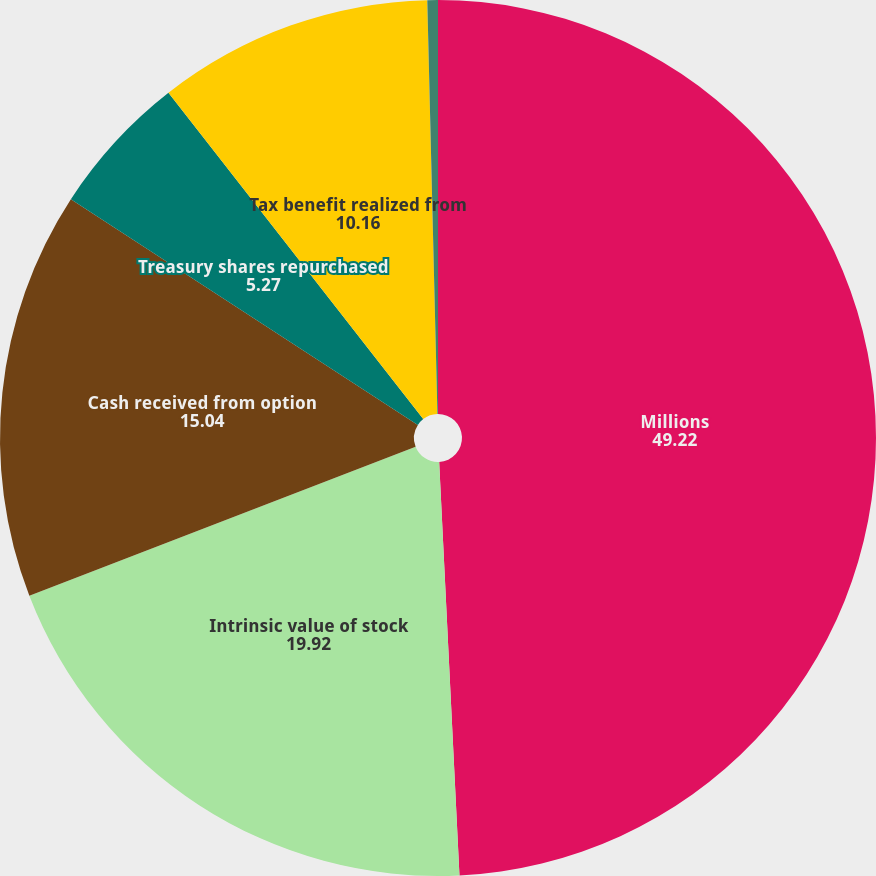<chart> <loc_0><loc_0><loc_500><loc_500><pie_chart><fcel>Millions<fcel>Intrinsic value of stock<fcel>Cash received from option<fcel>Treasury shares repurchased<fcel>Tax benefit realized from<fcel>Aggregate grant-date fair<nl><fcel>49.22%<fcel>19.92%<fcel>15.04%<fcel>5.27%<fcel>10.16%<fcel>0.39%<nl></chart> 